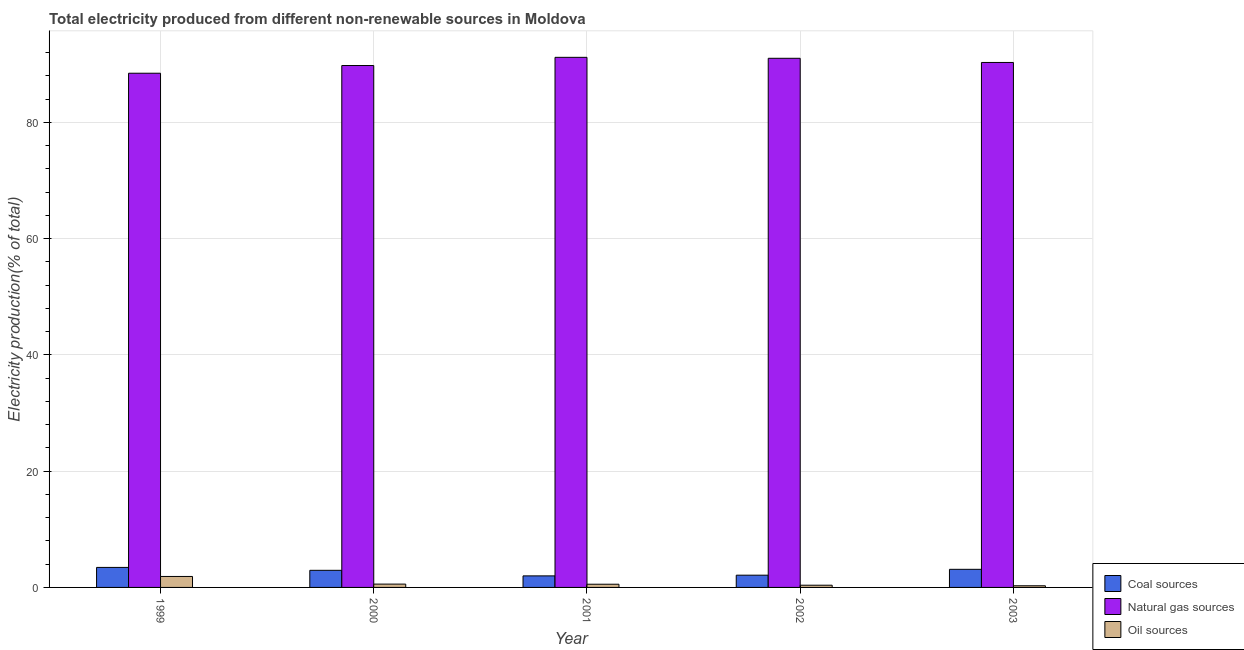How many bars are there on the 4th tick from the left?
Give a very brief answer. 3. How many bars are there on the 1st tick from the right?
Make the answer very short. 3. What is the label of the 3rd group of bars from the left?
Provide a succinct answer. 2001. What is the percentage of electricity produced by oil sources in 1999?
Your response must be concise. 1.89. Across all years, what is the maximum percentage of electricity produced by natural gas?
Keep it short and to the point. 91.17. Across all years, what is the minimum percentage of electricity produced by oil sources?
Offer a very short reply. 0.28. What is the total percentage of electricity produced by oil sources in the graph?
Keep it short and to the point. 3.67. What is the difference between the percentage of electricity produced by natural gas in 1999 and that in 2002?
Give a very brief answer. -2.57. What is the difference between the percentage of electricity produced by oil sources in 2003 and the percentage of electricity produced by coal in 2001?
Provide a short and direct response. -0.27. What is the average percentage of electricity produced by natural gas per year?
Your response must be concise. 90.13. In how many years, is the percentage of electricity produced by coal greater than 36 %?
Offer a terse response. 0. What is the ratio of the percentage of electricity produced by coal in 1999 to that in 2002?
Ensure brevity in your answer.  1.63. Is the percentage of electricity produced by coal in 2000 less than that in 2001?
Offer a very short reply. No. What is the difference between the highest and the second highest percentage of electricity produced by natural gas?
Offer a terse response. 0.16. What is the difference between the highest and the lowest percentage of electricity produced by oil sources?
Provide a succinct answer. 1.6. What does the 1st bar from the left in 2003 represents?
Your answer should be very brief. Coal sources. What does the 1st bar from the right in 1999 represents?
Your answer should be very brief. Oil sources. Is it the case that in every year, the sum of the percentage of electricity produced by coal and percentage of electricity produced by natural gas is greater than the percentage of electricity produced by oil sources?
Provide a succinct answer. Yes. How many bars are there?
Provide a short and direct response. 15. Are all the bars in the graph horizontal?
Provide a succinct answer. No. What is the difference between two consecutive major ticks on the Y-axis?
Keep it short and to the point. 20. How many legend labels are there?
Keep it short and to the point. 3. What is the title of the graph?
Give a very brief answer. Total electricity produced from different non-renewable sources in Moldova. Does "Natural gas sources" appear as one of the legend labels in the graph?
Offer a very short reply. Yes. What is the label or title of the Y-axis?
Offer a terse response. Electricity production(% of total). What is the Electricity production(% of total) in Coal sources in 1999?
Your answer should be compact. 3.44. What is the Electricity production(% of total) of Natural gas sources in 1999?
Offer a terse response. 88.44. What is the Electricity production(% of total) in Oil sources in 1999?
Your answer should be very brief. 1.89. What is the Electricity production(% of total) of Coal sources in 2000?
Your answer should be very brief. 2.94. What is the Electricity production(% of total) in Natural gas sources in 2000?
Keep it short and to the point. 89.76. What is the Electricity production(% of total) of Oil sources in 2000?
Offer a very short reply. 0.57. What is the Electricity production(% of total) in Coal sources in 2001?
Your answer should be compact. 1.99. What is the Electricity production(% of total) in Natural gas sources in 2001?
Provide a succinct answer. 91.17. What is the Electricity production(% of total) in Oil sources in 2001?
Your response must be concise. 0.55. What is the Electricity production(% of total) in Coal sources in 2002?
Give a very brief answer. 2.11. What is the Electricity production(% of total) of Natural gas sources in 2002?
Offer a terse response. 91.01. What is the Electricity production(% of total) in Oil sources in 2002?
Keep it short and to the point. 0.38. What is the Electricity production(% of total) in Coal sources in 2003?
Keep it short and to the point. 3.12. What is the Electricity production(% of total) in Natural gas sources in 2003?
Give a very brief answer. 90.29. What is the Electricity production(% of total) of Oil sources in 2003?
Your response must be concise. 0.28. Across all years, what is the maximum Electricity production(% of total) of Coal sources?
Your answer should be compact. 3.44. Across all years, what is the maximum Electricity production(% of total) in Natural gas sources?
Offer a terse response. 91.17. Across all years, what is the maximum Electricity production(% of total) of Oil sources?
Offer a terse response. 1.89. Across all years, what is the minimum Electricity production(% of total) of Coal sources?
Provide a short and direct response. 1.99. Across all years, what is the minimum Electricity production(% of total) in Natural gas sources?
Provide a short and direct response. 88.44. Across all years, what is the minimum Electricity production(% of total) of Oil sources?
Your answer should be compact. 0.28. What is the total Electricity production(% of total) in Coal sources in the graph?
Offer a terse response. 13.59. What is the total Electricity production(% of total) in Natural gas sources in the graph?
Give a very brief answer. 450.66. What is the total Electricity production(% of total) in Oil sources in the graph?
Provide a succinct answer. 3.67. What is the difference between the Electricity production(% of total) of Coal sources in 1999 and that in 2000?
Ensure brevity in your answer.  0.5. What is the difference between the Electricity production(% of total) in Natural gas sources in 1999 and that in 2000?
Give a very brief answer. -1.32. What is the difference between the Electricity production(% of total) in Oil sources in 1999 and that in 2000?
Keep it short and to the point. 1.31. What is the difference between the Electricity production(% of total) of Coal sources in 1999 and that in 2001?
Give a very brief answer. 1.45. What is the difference between the Electricity production(% of total) in Natural gas sources in 1999 and that in 2001?
Offer a terse response. -2.73. What is the difference between the Electricity production(% of total) of Oil sources in 1999 and that in 2001?
Provide a succinct answer. 1.33. What is the difference between the Electricity production(% of total) in Coal sources in 1999 and that in 2002?
Offer a terse response. 1.33. What is the difference between the Electricity production(% of total) of Natural gas sources in 1999 and that in 2002?
Provide a short and direct response. -2.57. What is the difference between the Electricity production(% of total) in Oil sources in 1999 and that in 2002?
Give a very brief answer. 1.51. What is the difference between the Electricity production(% of total) in Coal sources in 1999 and that in 2003?
Your answer should be compact. 0.33. What is the difference between the Electricity production(% of total) of Natural gas sources in 1999 and that in 2003?
Offer a terse response. -1.85. What is the difference between the Electricity production(% of total) of Oil sources in 1999 and that in 2003?
Give a very brief answer. 1.6. What is the difference between the Electricity production(% of total) of Coal sources in 2000 and that in 2001?
Provide a succinct answer. 0.96. What is the difference between the Electricity production(% of total) in Natural gas sources in 2000 and that in 2001?
Keep it short and to the point. -1.41. What is the difference between the Electricity production(% of total) of Oil sources in 2000 and that in 2001?
Your answer should be compact. 0.02. What is the difference between the Electricity production(% of total) in Coal sources in 2000 and that in 2002?
Keep it short and to the point. 0.84. What is the difference between the Electricity production(% of total) of Natural gas sources in 2000 and that in 2002?
Your answer should be compact. -1.25. What is the difference between the Electricity production(% of total) of Oil sources in 2000 and that in 2002?
Offer a terse response. 0.19. What is the difference between the Electricity production(% of total) of Coal sources in 2000 and that in 2003?
Ensure brevity in your answer.  -0.17. What is the difference between the Electricity production(% of total) in Natural gas sources in 2000 and that in 2003?
Give a very brief answer. -0.53. What is the difference between the Electricity production(% of total) of Oil sources in 2000 and that in 2003?
Offer a terse response. 0.29. What is the difference between the Electricity production(% of total) in Coal sources in 2001 and that in 2002?
Make the answer very short. -0.12. What is the difference between the Electricity production(% of total) in Natural gas sources in 2001 and that in 2002?
Offer a very short reply. 0.16. What is the difference between the Electricity production(% of total) in Oil sources in 2001 and that in 2002?
Your response must be concise. 0.17. What is the difference between the Electricity production(% of total) of Coal sources in 2001 and that in 2003?
Your response must be concise. -1.13. What is the difference between the Electricity production(% of total) in Natural gas sources in 2001 and that in 2003?
Offer a very short reply. 0.88. What is the difference between the Electricity production(% of total) in Oil sources in 2001 and that in 2003?
Provide a succinct answer. 0.27. What is the difference between the Electricity production(% of total) in Coal sources in 2002 and that in 2003?
Provide a succinct answer. -1.01. What is the difference between the Electricity production(% of total) in Natural gas sources in 2002 and that in 2003?
Your answer should be very brief. 0.72. What is the difference between the Electricity production(% of total) of Oil sources in 2002 and that in 2003?
Your answer should be very brief. 0.1. What is the difference between the Electricity production(% of total) of Coal sources in 1999 and the Electricity production(% of total) of Natural gas sources in 2000?
Provide a short and direct response. -86.32. What is the difference between the Electricity production(% of total) of Coal sources in 1999 and the Electricity production(% of total) of Oil sources in 2000?
Provide a short and direct response. 2.87. What is the difference between the Electricity production(% of total) of Natural gas sources in 1999 and the Electricity production(% of total) of Oil sources in 2000?
Offer a terse response. 87.87. What is the difference between the Electricity production(% of total) of Coal sources in 1999 and the Electricity production(% of total) of Natural gas sources in 2001?
Ensure brevity in your answer.  -87.73. What is the difference between the Electricity production(% of total) in Coal sources in 1999 and the Electricity production(% of total) in Oil sources in 2001?
Give a very brief answer. 2.89. What is the difference between the Electricity production(% of total) of Natural gas sources in 1999 and the Electricity production(% of total) of Oil sources in 2001?
Make the answer very short. 87.89. What is the difference between the Electricity production(% of total) in Coal sources in 1999 and the Electricity production(% of total) in Natural gas sources in 2002?
Provide a succinct answer. -87.57. What is the difference between the Electricity production(% of total) of Coal sources in 1999 and the Electricity production(% of total) of Oil sources in 2002?
Your answer should be compact. 3.06. What is the difference between the Electricity production(% of total) of Natural gas sources in 1999 and the Electricity production(% of total) of Oil sources in 2002?
Your answer should be compact. 88.06. What is the difference between the Electricity production(% of total) in Coal sources in 1999 and the Electricity production(% of total) in Natural gas sources in 2003?
Your answer should be very brief. -86.85. What is the difference between the Electricity production(% of total) of Coal sources in 1999 and the Electricity production(% of total) of Oil sources in 2003?
Keep it short and to the point. 3.16. What is the difference between the Electricity production(% of total) in Natural gas sources in 1999 and the Electricity production(% of total) in Oil sources in 2003?
Offer a terse response. 88.15. What is the difference between the Electricity production(% of total) of Coal sources in 2000 and the Electricity production(% of total) of Natural gas sources in 2001?
Make the answer very short. -88.23. What is the difference between the Electricity production(% of total) of Coal sources in 2000 and the Electricity production(% of total) of Oil sources in 2001?
Offer a very short reply. 2.39. What is the difference between the Electricity production(% of total) in Natural gas sources in 2000 and the Electricity production(% of total) in Oil sources in 2001?
Give a very brief answer. 89.21. What is the difference between the Electricity production(% of total) of Coal sources in 2000 and the Electricity production(% of total) of Natural gas sources in 2002?
Ensure brevity in your answer.  -88.06. What is the difference between the Electricity production(% of total) of Coal sources in 2000 and the Electricity production(% of total) of Oil sources in 2002?
Offer a terse response. 2.56. What is the difference between the Electricity production(% of total) in Natural gas sources in 2000 and the Electricity production(% of total) in Oil sources in 2002?
Offer a very short reply. 89.38. What is the difference between the Electricity production(% of total) of Coal sources in 2000 and the Electricity production(% of total) of Natural gas sources in 2003?
Your answer should be very brief. -87.34. What is the difference between the Electricity production(% of total) of Coal sources in 2000 and the Electricity production(% of total) of Oil sources in 2003?
Your answer should be compact. 2.66. What is the difference between the Electricity production(% of total) in Natural gas sources in 2000 and the Electricity production(% of total) in Oil sources in 2003?
Ensure brevity in your answer.  89.48. What is the difference between the Electricity production(% of total) in Coal sources in 2001 and the Electricity production(% of total) in Natural gas sources in 2002?
Give a very brief answer. -89.02. What is the difference between the Electricity production(% of total) in Coal sources in 2001 and the Electricity production(% of total) in Oil sources in 2002?
Your answer should be very brief. 1.61. What is the difference between the Electricity production(% of total) in Natural gas sources in 2001 and the Electricity production(% of total) in Oil sources in 2002?
Offer a terse response. 90.79. What is the difference between the Electricity production(% of total) in Coal sources in 2001 and the Electricity production(% of total) in Natural gas sources in 2003?
Offer a terse response. -88.3. What is the difference between the Electricity production(% of total) in Coal sources in 2001 and the Electricity production(% of total) in Oil sources in 2003?
Offer a terse response. 1.7. What is the difference between the Electricity production(% of total) of Natural gas sources in 2001 and the Electricity production(% of total) of Oil sources in 2003?
Make the answer very short. 90.89. What is the difference between the Electricity production(% of total) in Coal sources in 2002 and the Electricity production(% of total) in Natural gas sources in 2003?
Your response must be concise. -88.18. What is the difference between the Electricity production(% of total) in Coal sources in 2002 and the Electricity production(% of total) in Oil sources in 2003?
Your answer should be very brief. 1.82. What is the difference between the Electricity production(% of total) in Natural gas sources in 2002 and the Electricity production(% of total) in Oil sources in 2003?
Your response must be concise. 90.72. What is the average Electricity production(% of total) of Coal sources per year?
Offer a very short reply. 2.72. What is the average Electricity production(% of total) in Natural gas sources per year?
Offer a terse response. 90.13. What is the average Electricity production(% of total) of Oil sources per year?
Ensure brevity in your answer.  0.73. In the year 1999, what is the difference between the Electricity production(% of total) in Coal sources and Electricity production(% of total) in Natural gas sources?
Keep it short and to the point. -85. In the year 1999, what is the difference between the Electricity production(% of total) of Coal sources and Electricity production(% of total) of Oil sources?
Provide a succinct answer. 1.55. In the year 1999, what is the difference between the Electricity production(% of total) in Natural gas sources and Electricity production(% of total) in Oil sources?
Your answer should be very brief. 86.55. In the year 2000, what is the difference between the Electricity production(% of total) in Coal sources and Electricity production(% of total) in Natural gas sources?
Make the answer very short. -86.82. In the year 2000, what is the difference between the Electricity production(% of total) of Coal sources and Electricity production(% of total) of Oil sources?
Offer a very short reply. 2.37. In the year 2000, what is the difference between the Electricity production(% of total) of Natural gas sources and Electricity production(% of total) of Oil sources?
Offer a terse response. 89.19. In the year 2001, what is the difference between the Electricity production(% of total) of Coal sources and Electricity production(% of total) of Natural gas sources?
Your answer should be very brief. -89.18. In the year 2001, what is the difference between the Electricity production(% of total) in Coal sources and Electricity production(% of total) in Oil sources?
Your answer should be compact. 1.44. In the year 2001, what is the difference between the Electricity production(% of total) in Natural gas sources and Electricity production(% of total) in Oil sources?
Offer a very short reply. 90.62. In the year 2002, what is the difference between the Electricity production(% of total) in Coal sources and Electricity production(% of total) in Natural gas sources?
Your response must be concise. -88.9. In the year 2002, what is the difference between the Electricity production(% of total) of Coal sources and Electricity production(% of total) of Oil sources?
Provide a succinct answer. 1.73. In the year 2002, what is the difference between the Electricity production(% of total) of Natural gas sources and Electricity production(% of total) of Oil sources?
Your answer should be very brief. 90.63. In the year 2003, what is the difference between the Electricity production(% of total) of Coal sources and Electricity production(% of total) of Natural gas sources?
Your answer should be very brief. -87.17. In the year 2003, what is the difference between the Electricity production(% of total) in Coal sources and Electricity production(% of total) in Oil sources?
Make the answer very short. 2.83. In the year 2003, what is the difference between the Electricity production(% of total) in Natural gas sources and Electricity production(% of total) in Oil sources?
Give a very brief answer. 90. What is the ratio of the Electricity production(% of total) in Coal sources in 1999 to that in 2000?
Your answer should be very brief. 1.17. What is the ratio of the Electricity production(% of total) of Natural gas sources in 1999 to that in 2000?
Your response must be concise. 0.99. What is the ratio of the Electricity production(% of total) of Oil sources in 1999 to that in 2000?
Provide a short and direct response. 3.3. What is the ratio of the Electricity production(% of total) in Coal sources in 1999 to that in 2001?
Your answer should be very brief. 1.73. What is the ratio of the Electricity production(% of total) in Natural gas sources in 1999 to that in 2001?
Your response must be concise. 0.97. What is the ratio of the Electricity production(% of total) in Oil sources in 1999 to that in 2001?
Your answer should be very brief. 3.42. What is the ratio of the Electricity production(% of total) in Coal sources in 1999 to that in 2002?
Ensure brevity in your answer.  1.63. What is the ratio of the Electricity production(% of total) in Natural gas sources in 1999 to that in 2002?
Your response must be concise. 0.97. What is the ratio of the Electricity production(% of total) of Oil sources in 1999 to that in 2002?
Keep it short and to the point. 4.97. What is the ratio of the Electricity production(% of total) in Coal sources in 1999 to that in 2003?
Your answer should be compact. 1.1. What is the ratio of the Electricity production(% of total) in Natural gas sources in 1999 to that in 2003?
Your response must be concise. 0.98. What is the ratio of the Electricity production(% of total) in Oil sources in 1999 to that in 2003?
Offer a very short reply. 6.62. What is the ratio of the Electricity production(% of total) in Coal sources in 2000 to that in 2001?
Your answer should be compact. 1.48. What is the ratio of the Electricity production(% of total) in Natural gas sources in 2000 to that in 2001?
Offer a terse response. 0.98. What is the ratio of the Electricity production(% of total) of Oil sources in 2000 to that in 2001?
Your response must be concise. 1.04. What is the ratio of the Electricity production(% of total) in Coal sources in 2000 to that in 2002?
Your response must be concise. 1.4. What is the ratio of the Electricity production(% of total) in Natural gas sources in 2000 to that in 2002?
Make the answer very short. 0.99. What is the ratio of the Electricity production(% of total) in Oil sources in 2000 to that in 2002?
Give a very brief answer. 1.5. What is the ratio of the Electricity production(% of total) in Coal sources in 2000 to that in 2003?
Ensure brevity in your answer.  0.94. What is the ratio of the Electricity production(% of total) in Natural gas sources in 2000 to that in 2003?
Provide a short and direct response. 0.99. What is the ratio of the Electricity production(% of total) of Oil sources in 2000 to that in 2003?
Your answer should be compact. 2. What is the ratio of the Electricity production(% of total) of Coal sources in 2001 to that in 2002?
Make the answer very short. 0.94. What is the ratio of the Electricity production(% of total) in Natural gas sources in 2001 to that in 2002?
Provide a short and direct response. 1. What is the ratio of the Electricity production(% of total) in Oil sources in 2001 to that in 2002?
Offer a terse response. 1.45. What is the ratio of the Electricity production(% of total) in Coal sources in 2001 to that in 2003?
Provide a short and direct response. 0.64. What is the ratio of the Electricity production(% of total) in Natural gas sources in 2001 to that in 2003?
Give a very brief answer. 1.01. What is the ratio of the Electricity production(% of total) in Oil sources in 2001 to that in 2003?
Give a very brief answer. 1.93. What is the ratio of the Electricity production(% of total) of Coal sources in 2002 to that in 2003?
Keep it short and to the point. 0.68. What is the ratio of the Electricity production(% of total) of Natural gas sources in 2002 to that in 2003?
Provide a succinct answer. 1.01. What is the ratio of the Electricity production(% of total) of Oil sources in 2002 to that in 2003?
Your answer should be compact. 1.33. What is the difference between the highest and the second highest Electricity production(% of total) in Coal sources?
Your answer should be very brief. 0.33. What is the difference between the highest and the second highest Electricity production(% of total) of Natural gas sources?
Make the answer very short. 0.16. What is the difference between the highest and the second highest Electricity production(% of total) of Oil sources?
Make the answer very short. 1.31. What is the difference between the highest and the lowest Electricity production(% of total) of Coal sources?
Keep it short and to the point. 1.45. What is the difference between the highest and the lowest Electricity production(% of total) of Natural gas sources?
Provide a short and direct response. 2.73. What is the difference between the highest and the lowest Electricity production(% of total) of Oil sources?
Offer a terse response. 1.6. 